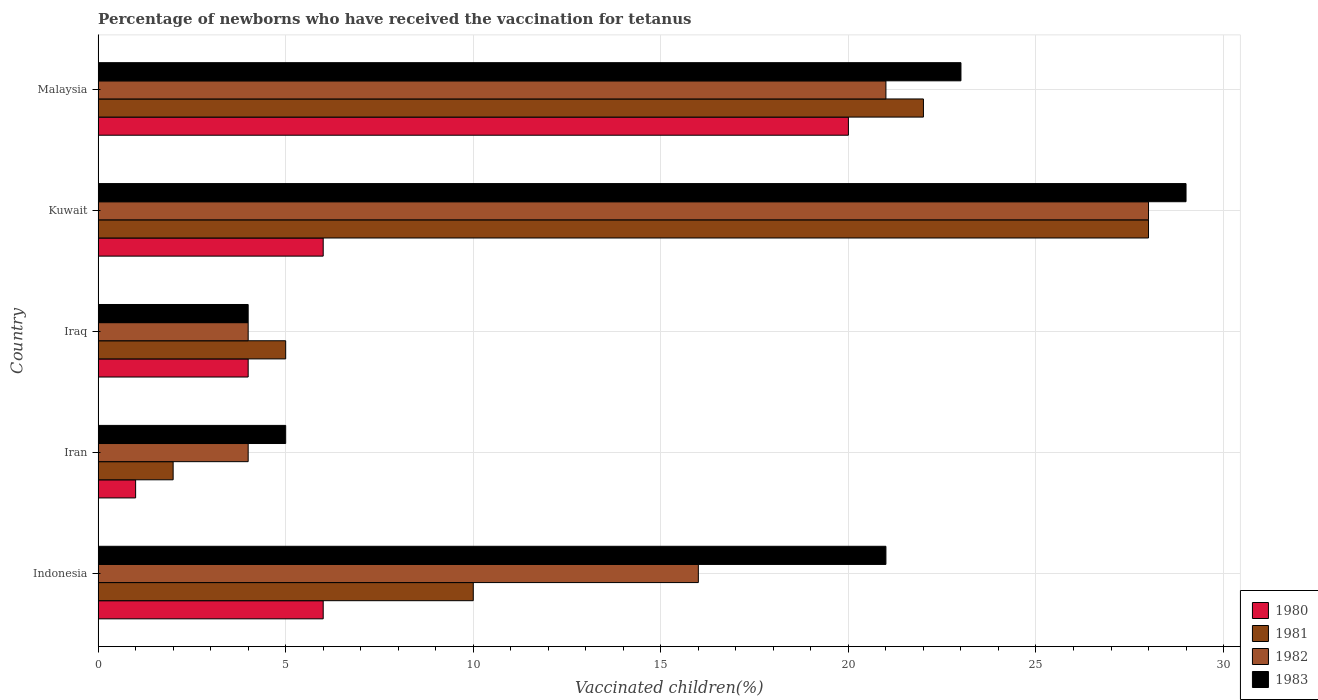How many different coloured bars are there?
Your answer should be compact. 4. Are the number of bars per tick equal to the number of legend labels?
Provide a short and direct response. Yes. How many bars are there on the 1st tick from the top?
Provide a short and direct response. 4. What is the label of the 2nd group of bars from the top?
Your answer should be compact. Kuwait. In how many cases, is the number of bars for a given country not equal to the number of legend labels?
Your answer should be very brief. 0. What is the percentage of vaccinated children in 1981 in Indonesia?
Keep it short and to the point. 10. Across all countries, what is the minimum percentage of vaccinated children in 1980?
Your answer should be very brief. 1. In which country was the percentage of vaccinated children in 1981 maximum?
Give a very brief answer. Kuwait. In which country was the percentage of vaccinated children in 1982 minimum?
Ensure brevity in your answer.  Iran. What is the total percentage of vaccinated children in 1983 in the graph?
Give a very brief answer. 82. What is the difference between the percentage of vaccinated children in 1980 in Kuwait and that in Malaysia?
Keep it short and to the point. -14. What is the difference between the percentage of vaccinated children in 1980 in Indonesia and the percentage of vaccinated children in 1982 in Iraq?
Give a very brief answer. 2. In how many countries, is the percentage of vaccinated children in 1983 greater than 25 %?
Provide a short and direct response. 1. What is the ratio of the percentage of vaccinated children in 1981 in Indonesia to that in Malaysia?
Provide a succinct answer. 0.45. Is the difference between the percentage of vaccinated children in 1981 in Indonesia and Malaysia greater than the difference between the percentage of vaccinated children in 1980 in Indonesia and Malaysia?
Keep it short and to the point. Yes. What is the difference between the highest and the second highest percentage of vaccinated children in 1981?
Your answer should be very brief. 6. In how many countries, is the percentage of vaccinated children in 1981 greater than the average percentage of vaccinated children in 1981 taken over all countries?
Your answer should be very brief. 2. How many bars are there?
Your response must be concise. 20. How many countries are there in the graph?
Keep it short and to the point. 5. Are the values on the major ticks of X-axis written in scientific E-notation?
Ensure brevity in your answer.  No. Does the graph contain any zero values?
Keep it short and to the point. No. Does the graph contain grids?
Keep it short and to the point. Yes. How many legend labels are there?
Give a very brief answer. 4. What is the title of the graph?
Offer a terse response. Percentage of newborns who have received the vaccination for tetanus. Does "1970" appear as one of the legend labels in the graph?
Offer a terse response. No. What is the label or title of the X-axis?
Your answer should be very brief. Vaccinated children(%). What is the label or title of the Y-axis?
Keep it short and to the point. Country. What is the Vaccinated children(%) of 1982 in Indonesia?
Give a very brief answer. 16. What is the Vaccinated children(%) of 1980 in Iran?
Ensure brevity in your answer.  1. What is the Vaccinated children(%) of 1982 in Iran?
Your answer should be compact. 4. What is the Vaccinated children(%) in 1981 in Iraq?
Your response must be concise. 5. What is the Vaccinated children(%) of 1982 in Iraq?
Offer a terse response. 4. What is the Vaccinated children(%) in 1983 in Iraq?
Your answer should be compact. 4. What is the Vaccinated children(%) in 1981 in Kuwait?
Keep it short and to the point. 28. What is the Vaccinated children(%) in 1980 in Malaysia?
Your answer should be compact. 20. What is the Vaccinated children(%) of 1982 in Malaysia?
Provide a short and direct response. 21. Across all countries, what is the maximum Vaccinated children(%) in 1980?
Provide a short and direct response. 20. Across all countries, what is the minimum Vaccinated children(%) in 1980?
Your answer should be very brief. 1. Across all countries, what is the minimum Vaccinated children(%) of 1983?
Ensure brevity in your answer.  4. What is the total Vaccinated children(%) in 1982 in the graph?
Provide a succinct answer. 73. What is the difference between the Vaccinated children(%) in 1980 in Indonesia and that in Iran?
Ensure brevity in your answer.  5. What is the difference between the Vaccinated children(%) in 1981 in Indonesia and that in Iran?
Give a very brief answer. 8. What is the difference between the Vaccinated children(%) of 1980 in Indonesia and that in Iraq?
Provide a succinct answer. 2. What is the difference between the Vaccinated children(%) of 1982 in Indonesia and that in Iraq?
Provide a short and direct response. 12. What is the difference between the Vaccinated children(%) of 1983 in Indonesia and that in Iraq?
Your answer should be compact. 17. What is the difference between the Vaccinated children(%) of 1980 in Indonesia and that in Kuwait?
Make the answer very short. 0. What is the difference between the Vaccinated children(%) of 1981 in Indonesia and that in Kuwait?
Offer a terse response. -18. What is the difference between the Vaccinated children(%) of 1981 in Indonesia and that in Malaysia?
Make the answer very short. -12. What is the difference between the Vaccinated children(%) of 1980 in Iran and that in Iraq?
Your answer should be very brief. -3. What is the difference between the Vaccinated children(%) in 1980 in Iran and that in Kuwait?
Keep it short and to the point. -5. What is the difference between the Vaccinated children(%) of 1981 in Iran and that in Kuwait?
Give a very brief answer. -26. What is the difference between the Vaccinated children(%) of 1982 in Iran and that in Malaysia?
Make the answer very short. -17. What is the difference between the Vaccinated children(%) of 1982 in Iraq and that in Kuwait?
Your response must be concise. -24. What is the difference between the Vaccinated children(%) of 1981 in Iraq and that in Malaysia?
Your response must be concise. -17. What is the difference between the Vaccinated children(%) of 1982 in Iraq and that in Malaysia?
Give a very brief answer. -17. What is the difference between the Vaccinated children(%) of 1983 in Iraq and that in Malaysia?
Your answer should be very brief. -19. What is the difference between the Vaccinated children(%) of 1980 in Indonesia and the Vaccinated children(%) of 1981 in Iran?
Provide a succinct answer. 4. What is the difference between the Vaccinated children(%) of 1980 in Indonesia and the Vaccinated children(%) of 1983 in Iran?
Provide a short and direct response. 1. What is the difference between the Vaccinated children(%) in 1980 in Indonesia and the Vaccinated children(%) in 1983 in Iraq?
Provide a short and direct response. 2. What is the difference between the Vaccinated children(%) of 1982 in Indonesia and the Vaccinated children(%) of 1983 in Iraq?
Ensure brevity in your answer.  12. What is the difference between the Vaccinated children(%) in 1980 in Indonesia and the Vaccinated children(%) in 1982 in Kuwait?
Your response must be concise. -22. What is the difference between the Vaccinated children(%) of 1982 in Indonesia and the Vaccinated children(%) of 1983 in Kuwait?
Make the answer very short. -13. What is the difference between the Vaccinated children(%) of 1980 in Indonesia and the Vaccinated children(%) of 1981 in Malaysia?
Keep it short and to the point. -16. What is the difference between the Vaccinated children(%) of 1980 in Indonesia and the Vaccinated children(%) of 1982 in Malaysia?
Make the answer very short. -15. What is the difference between the Vaccinated children(%) in 1981 in Indonesia and the Vaccinated children(%) in 1982 in Malaysia?
Keep it short and to the point. -11. What is the difference between the Vaccinated children(%) in 1982 in Indonesia and the Vaccinated children(%) in 1983 in Malaysia?
Your answer should be compact. -7. What is the difference between the Vaccinated children(%) in 1980 in Iran and the Vaccinated children(%) in 1981 in Iraq?
Your answer should be very brief. -4. What is the difference between the Vaccinated children(%) in 1980 in Iran and the Vaccinated children(%) in 1982 in Iraq?
Your answer should be very brief. -3. What is the difference between the Vaccinated children(%) in 1981 in Iran and the Vaccinated children(%) in 1983 in Iraq?
Your response must be concise. -2. What is the difference between the Vaccinated children(%) in 1980 in Iran and the Vaccinated children(%) in 1981 in Kuwait?
Keep it short and to the point. -27. What is the difference between the Vaccinated children(%) of 1980 in Iran and the Vaccinated children(%) of 1983 in Kuwait?
Your answer should be very brief. -28. What is the difference between the Vaccinated children(%) in 1982 in Iran and the Vaccinated children(%) in 1983 in Kuwait?
Make the answer very short. -25. What is the difference between the Vaccinated children(%) of 1980 in Iran and the Vaccinated children(%) of 1982 in Malaysia?
Provide a short and direct response. -20. What is the difference between the Vaccinated children(%) of 1980 in Iran and the Vaccinated children(%) of 1983 in Malaysia?
Provide a succinct answer. -22. What is the difference between the Vaccinated children(%) in 1982 in Iran and the Vaccinated children(%) in 1983 in Malaysia?
Provide a short and direct response. -19. What is the difference between the Vaccinated children(%) of 1980 in Iraq and the Vaccinated children(%) of 1981 in Kuwait?
Provide a succinct answer. -24. What is the difference between the Vaccinated children(%) of 1980 in Iraq and the Vaccinated children(%) of 1982 in Kuwait?
Offer a very short reply. -24. What is the difference between the Vaccinated children(%) in 1982 in Iraq and the Vaccinated children(%) in 1983 in Kuwait?
Keep it short and to the point. -25. What is the difference between the Vaccinated children(%) in 1980 in Iraq and the Vaccinated children(%) in 1981 in Malaysia?
Keep it short and to the point. -18. What is the difference between the Vaccinated children(%) in 1981 in Iraq and the Vaccinated children(%) in 1983 in Malaysia?
Keep it short and to the point. -18. What is the difference between the Vaccinated children(%) in 1980 in Kuwait and the Vaccinated children(%) in 1981 in Malaysia?
Your answer should be very brief. -16. What is the difference between the Vaccinated children(%) in 1980 in Kuwait and the Vaccinated children(%) in 1982 in Malaysia?
Ensure brevity in your answer.  -15. What is the difference between the Vaccinated children(%) of 1981 in Kuwait and the Vaccinated children(%) of 1982 in Malaysia?
Offer a terse response. 7. What is the average Vaccinated children(%) in 1981 per country?
Provide a short and direct response. 13.4. What is the average Vaccinated children(%) in 1983 per country?
Give a very brief answer. 16.4. What is the difference between the Vaccinated children(%) of 1980 and Vaccinated children(%) of 1983 in Indonesia?
Your answer should be very brief. -15. What is the difference between the Vaccinated children(%) in 1981 and Vaccinated children(%) in 1982 in Indonesia?
Provide a short and direct response. -6. What is the difference between the Vaccinated children(%) in 1982 and Vaccinated children(%) in 1983 in Indonesia?
Provide a short and direct response. -5. What is the difference between the Vaccinated children(%) in 1980 and Vaccinated children(%) in 1981 in Iran?
Offer a very short reply. -1. What is the difference between the Vaccinated children(%) of 1980 and Vaccinated children(%) of 1982 in Iran?
Your response must be concise. -3. What is the difference between the Vaccinated children(%) of 1981 and Vaccinated children(%) of 1982 in Iran?
Provide a short and direct response. -2. What is the difference between the Vaccinated children(%) of 1980 and Vaccinated children(%) of 1981 in Iraq?
Offer a terse response. -1. What is the difference between the Vaccinated children(%) in 1980 and Vaccinated children(%) in 1982 in Iraq?
Your answer should be very brief. 0. What is the difference between the Vaccinated children(%) in 1980 and Vaccinated children(%) in 1983 in Iraq?
Provide a succinct answer. 0. What is the difference between the Vaccinated children(%) of 1981 and Vaccinated children(%) of 1982 in Iraq?
Make the answer very short. 1. What is the difference between the Vaccinated children(%) in 1980 and Vaccinated children(%) in 1981 in Kuwait?
Provide a succinct answer. -22. What is the difference between the Vaccinated children(%) in 1980 and Vaccinated children(%) in 1982 in Kuwait?
Make the answer very short. -22. What is the difference between the Vaccinated children(%) in 1981 and Vaccinated children(%) in 1983 in Kuwait?
Offer a very short reply. -1. What is the difference between the Vaccinated children(%) of 1982 and Vaccinated children(%) of 1983 in Kuwait?
Ensure brevity in your answer.  -1. What is the difference between the Vaccinated children(%) of 1980 and Vaccinated children(%) of 1981 in Malaysia?
Make the answer very short. -2. What is the difference between the Vaccinated children(%) in 1980 and Vaccinated children(%) in 1983 in Malaysia?
Ensure brevity in your answer.  -3. What is the difference between the Vaccinated children(%) in 1981 and Vaccinated children(%) in 1982 in Malaysia?
Give a very brief answer. 1. What is the difference between the Vaccinated children(%) in 1981 and Vaccinated children(%) in 1983 in Malaysia?
Your answer should be very brief. -1. What is the difference between the Vaccinated children(%) in 1982 and Vaccinated children(%) in 1983 in Malaysia?
Your answer should be compact. -2. What is the ratio of the Vaccinated children(%) of 1980 in Indonesia to that in Iran?
Make the answer very short. 6. What is the ratio of the Vaccinated children(%) of 1981 in Indonesia to that in Iran?
Make the answer very short. 5. What is the ratio of the Vaccinated children(%) in 1980 in Indonesia to that in Iraq?
Your answer should be compact. 1.5. What is the ratio of the Vaccinated children(%) of 1981 in Indonesia to that in Iraq?
Keep it short and to the point. 2. What is the ratio of the Vaccinated children(%) of 1983 in Indonesia to that in Iraq?
Offer a very short reply. 5.25. What is the ratio of the Vaccinated children(%) of 1980 in Indonesia to that in Kuwait?
Make the answer very short. 1. What is the ratio of the Vaccinated children(%) in 1981 in Indonesia to that in Kuwait?
Give a very brief answer. 0.36. What is the ratio of the Vaccinated children(%) in 1983 in Indonesia to that in Kuwait?
Give a very brief answer. 0.72. What is the ratio of the Vaccinated children(%) of 1980 in Indonesia to that in Malaysia?
Provide a succinct answer. 0.3. What is the ratio of the Vaccinated children(%) in 1981 in Indonesia to that in Malaysia?
Your answer should be very brief. 0.45. What is the ratio of the Vaccinated children(%) of 1982 in Indonesia to that in Malaysia?
Ensure brevity in your answer.  0.76. What is the ratio of the Vaccinated children(%) of 1983 in Indonesia to that in Malaysia?
Your answer should be compact. 0.91. What is the ratio of the Vaccinated children(%) in 1980 in Iran to that in Kuwait?
Ensure brevity in your answer.  0.17. What is the ratio of the Vaccinated children(%) in 1981 in Iran to that in Kuwait?
Keep it short and to the point. 0.07. What is the ratio of the Vaccinated children(%) in 1982 in Iran to that in Kuwait?
Make the answer very short. 0.14. What is the ratio of the Vaccinated children(%) in 1983 in Iran to that in Kuwait?
Provide a succinct answer. 0.17. What is the ratio of the Vaccinated children(%) in 1980 in Iran to that in Malaysia?
Your answer should be compact. 0.05. What is the ratio of the Vaccinated children(%) of 1981 in Iran to that in Malaysia?
Give a very brief answer. 0.09. What is the ratio of the Vaccinated children(%) in 1982 in Iran to that in Malaysia?
Your answer should be compact. 0.19. What is the ratio of the Vaccinated children(%) in 1983 in Iran to that in Malaysia?
Your response must be concise. 0.22. What is the ratio of the Vaccinated children(%) in 1980 in Iraq to that in Kuwait?
Provide a succinct answer. 0.67. What is the ratio of the Vaccinated children(%) in 1981 in Iraq to that in Kuwait?
Your answer should be very brief. 0.18. What is the ratio of the Vaccinated children(%) of 1982 in Iraq to that in Kuwait?
Provide a short and direct response. 0.14. What is the ratio of the Vaccinated children(%) in 1983 in Iraq to that in Kuwait?
Your answer should be very brief. 0.14. What is the ratio of the Vaccinated children(%) in 1980 in Iraq to that in Malaysia?
Provide a short and direct response. 0.2. What is the ratio of the Vaccinated children(%) in 1981 in Iraq to that in Malaysia?
Provide a short and direct response. 0.23. What is the ratio of the Vaccinated children(%) of 1982 in Iraq to that in Malaysia?
Your response must be concise. 0.19. What is the ratio of the Vaccinated children(%) in 1983 in Iraq to that in Malaysia?
Make the answer very short. 0.17. What is the ratio of the Vaccinated children(%) in 1980 in Kuwait to that in Malaysia?
Your response must be concise. 0.3. What is the ratio of the Vaccinated children(%) in 1981 in Kuwait to that in Malaysia?
Offer a terse response. 1.27. What is the ratio of the Vaccinated children(%) in 1982 in Kuwait to that in Malaysia?
Offer a very short reply. 1.33. What is the ratio of the Vaccinated children(%) in 1983 in Kuwait to that in Malaysia?
Keep it short and to the point. 1.26. What is the difference between the highest and the second highest Vaccinated children(%) in 1982?
Provide a succinct answer. 7. What is the difference between the highest and the second highest Vaccinated children(%) in 1983?
Ensure brevity in your answer.  6. What is the difference between the highest and the lowest Vaccinated children(%) of 1982?
Your response must be concise. 24. What is the difference between the highest and the lowest Vaccinated children(%) of 1983?
Offer a terse response. 25. 